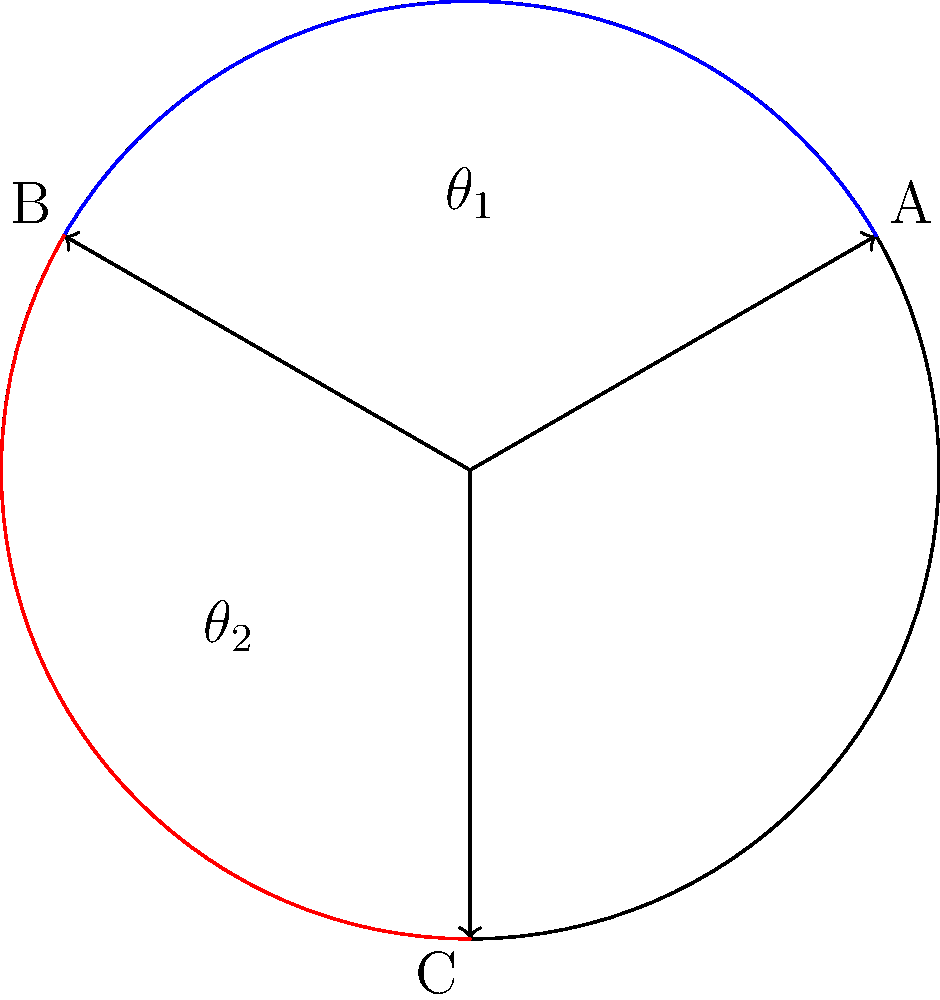On a standard dartboard, three throw lines are drawn from the center to points A, B, and C. The angle between A and B is $\theta_1$, and the angle between B and C is $\theta_2$. If $\theta_1 = 120°$ and $\theta_2 = 120°$, what is the angle between A and C? Let's approach this step-by-step:

1) First, recall that a complete circle contains 360°.

2) We are given two angles:
   $\theta_1 = 120°$ (between A and B)
   $\theta_2 = 120°$ (between B and C)

3) Let's call the angle we're looking for (between A and C) $\theta_3$.

4) We know that the sum of all angles around the center of the circle must equal 360°:

   $\theta_1 + \theta_2 + \theta_3 = 360°$

5) Substituting the known values:

   $120° + 120° + \theta_3 = 360°$

6) Simplify:

   $240° + \theta_3 = 360°$

7) Subtract 240° from both sides:

   $\theta_3 = 360° - 240° = 120°$

Therefore, the angle between A and C is also 120°.
Answer: 120° 